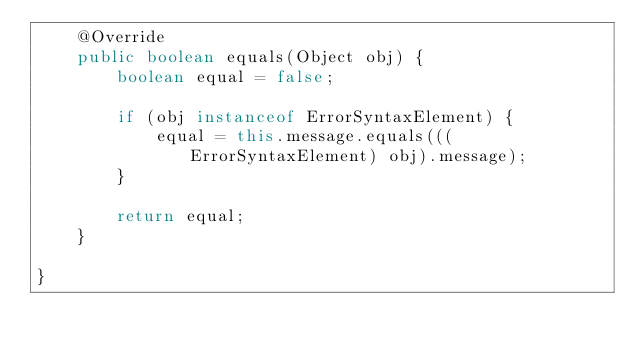<code> <loc_0><loc_0><loc_500><loc_500><_Java_>    @Override
    public boolean equals(Object obj) {
        boolean equal = false;
        
        if (obj instanceof ErrorSyntaxElement) {
            equal = this.message.equals(((ErrorSyntaxElement) obj).message);
        }
        
        return equal;
    }
    
}
</code> 